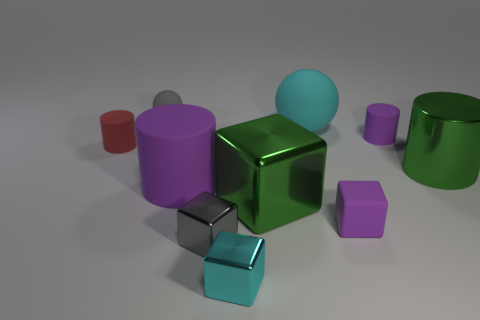Subtract all gray cubes. How many purple cylinders are left? 2 Subtract all green metal cylinders. How many cylinders are left? 3 Subtract 1 cylinders. How many cylinders are left? 3 Subtract all cyan cubes. How many cubes are left? 3 Subtract all blocks. How many objects are left? 6 Subtract all yellow blocks. Subtract all gray cylinders. How many blocks are left? 4 Add 2 large purple objects. How many large purple objects are left? 3 Add 4 gray objects. How many gray objects exist? 6 Subtract 0 brown blocks. How many objects are left? 10 Subtract all small brown metal spheres. Subtract all purple things. How many objects are left? 7 